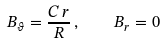Convert formula to latex. <formula><loc_0><loc_0><loc_500><loc_500>B _ { \vartheta } = \frac { C \, r } { R } \, , \quad B _ { r } = 0</formula> 